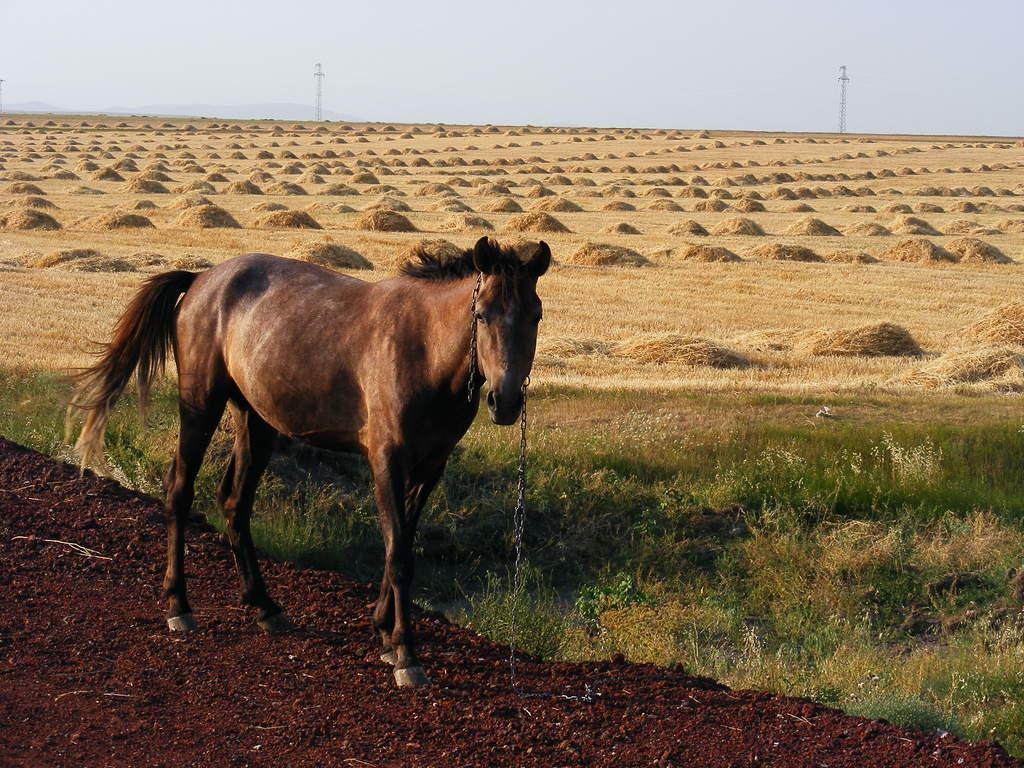What type of animal is in the image? There is an animal in the image, but its specific type cannot be determined from the provided facts. What color is the animal in the image? The animal is brown in color. What type of vegetation is present in the image? There is green and dried grass in the image. What can be seen in the background of the image? The sky is visible in the background of the image. What degree does the elbow of the animal have in the image? There is no mention of an elbow in the image, as animals do not have elbows. 